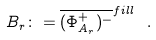Convert formula to latex. <formula><loc_0><loc_0><loc_500><loc_500>B _ { r } \colon = \overline { ( \Phi ^ { + } _ { A _ { r } } ) ^ { - } } ^ { f i l l } \ .</formula> 